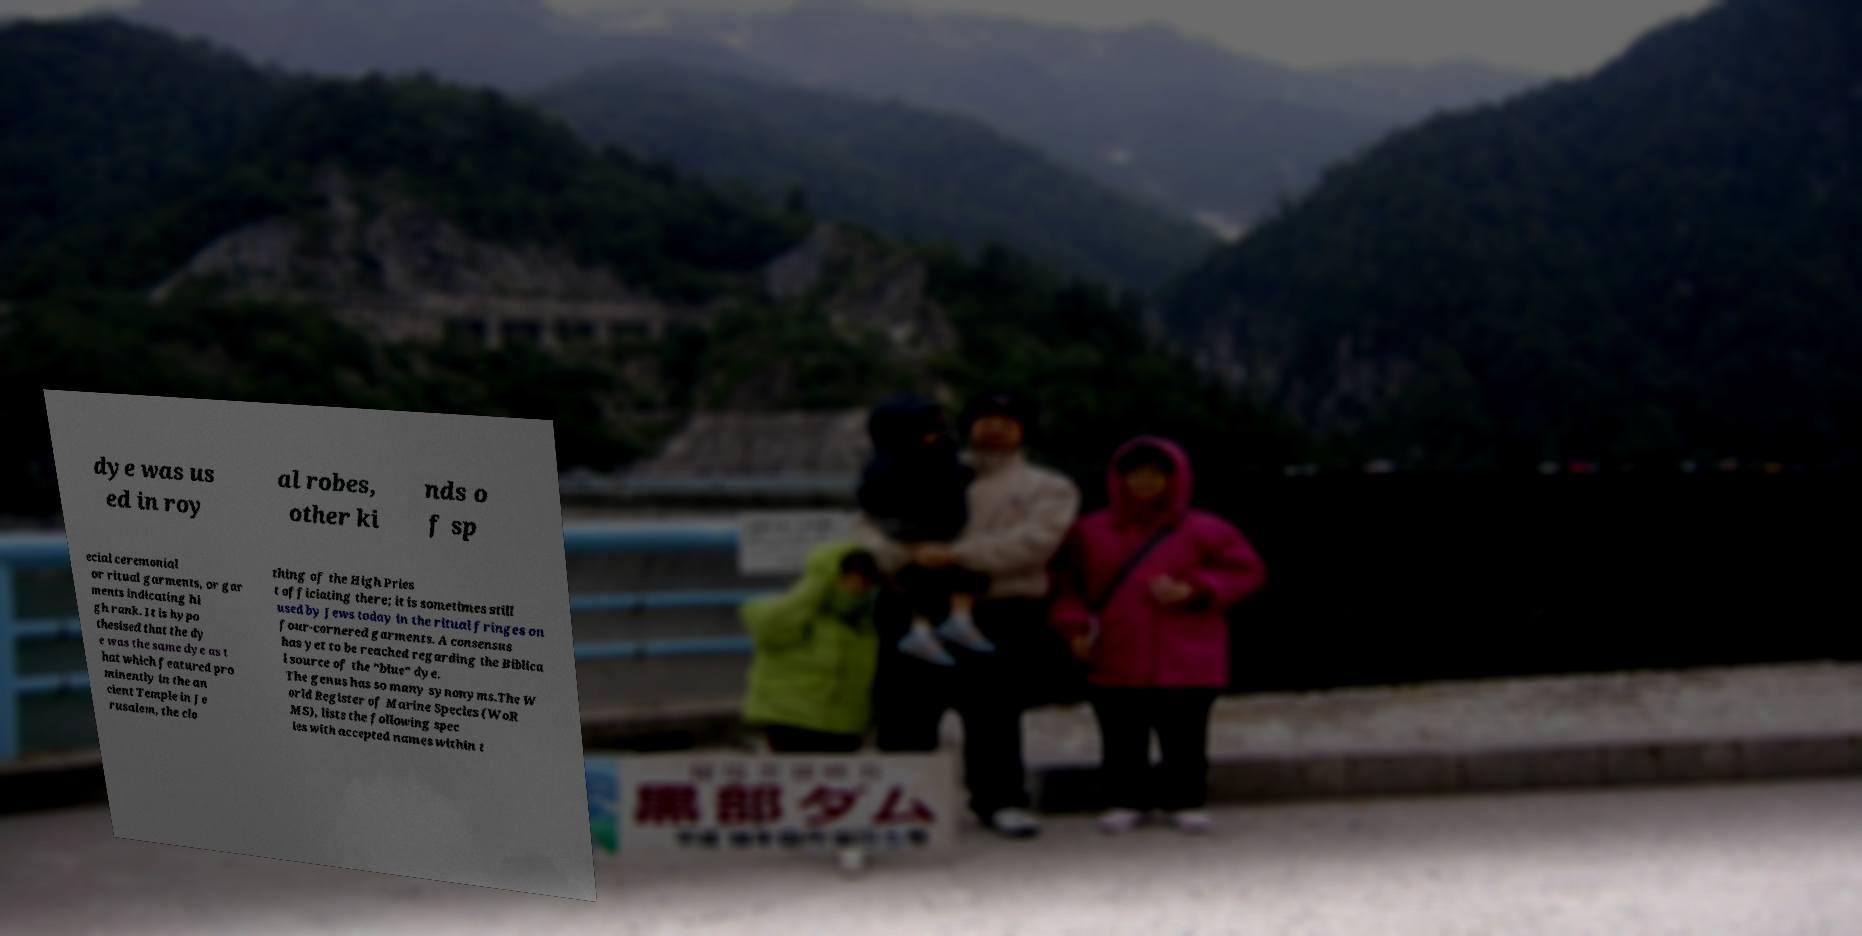I need the written content from this picture converted into text. Can you do that? dye was us ed in roy al robes, other ki nds o f sp ecial ceremonial or ritual garments, or gar ments indicating hi gh rank. It is hypo thesised that the dy e was the same dye as t hat which featured pro minently in the an cient Temple in Je rusalem, the clo thing of the High Pries t officiating there; it is sometimes still used by Jews today in the ritual fringes on four-cornered garments. A consensus has yet to be reached regarding the Biblica l source of the "blue" dye. The genus has so many synonyms.The W orld Register of Marine Species (WoR MS), lists the following spec ies with accepted names within t 